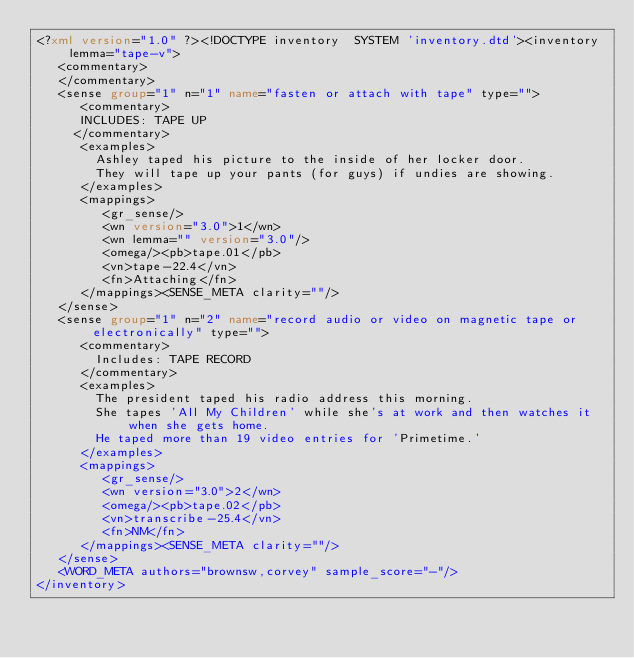Convert code to text. <code><loc_0><loc_0><loc_500><loc_500><_XML_><?xml version="1.0" ?><!DOCTYPE inventory  SYSTEM 'inventory.dtd'><inventory lemma="tape-v">
   <commentary>
   </commentary>
   <sense group="1" n="1" name="fasten or attach with tape" type="">
      <commentary>
      INCLUDES: TAPE UP
     </commentary>
      <examples>
        Ashley taped his picture to the inside of her locker door.
        They will tape up your pants (for guys) if undies are showing.
      </examples>
      <mappings>
         <gr_sense/>
         <wn version="3.0">1</wn>
         <wn lemma="" version="3.0"/>
         <omega/><pb>tape.01</pb>
         <vn>tape-22.4</vn>
         <fn>Attaching</fn>
      </mappings><SENSE_META clarity=""/>
   </sense>
   <sense group="1" n="2" name="record audio or video on magnetic tape or electronically" type="">
      <commentary>
        Includes: TAPE RECORD
      </commentary>
      <examples>
        The president taped his radio address this morning.
        She tapes 'All My Children' while she's at work and then watches it when she gets home.
        He taped more than 19 video entries for 'Primetime.'
      </examples>
      <mappings>
         <gr_sense/>
         <wn version="3.0">2</wn>
         <omega/><pb>tape.02</pb>
         <vn>transcribe-25.4</vn>
         <fn>NM</fn>
      </mappings><SENSE_META clarity=""/>
   </sense>
   <WORD_META authors="brownsw,corvey" sample_score="-"/>
</inventory></code> 